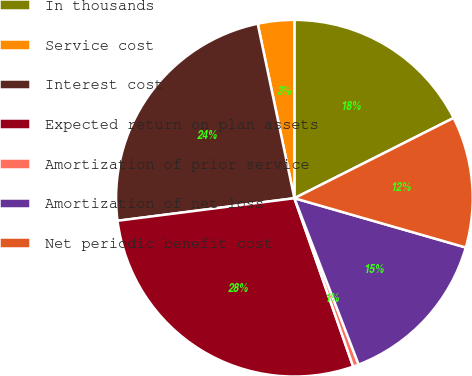Convert chart to OTSL. <chart><loc_0><loc_0><loc_500><loc_500><pie_chart><fcel>In thousands<fcel>Service cost<fcel>Interest cost<fcel>Expected return on plan assets<fcel>Amortization of prior service<fcel>Amortization of net loss<fcel>Net periodic benefit cost<nl><fcel>17.57%<fcel>3.3%<fcel>23.72%<fcel>28.33%<fcel>0.52%<fcel>14.68%<fcel>11.89%<nl></chart> 